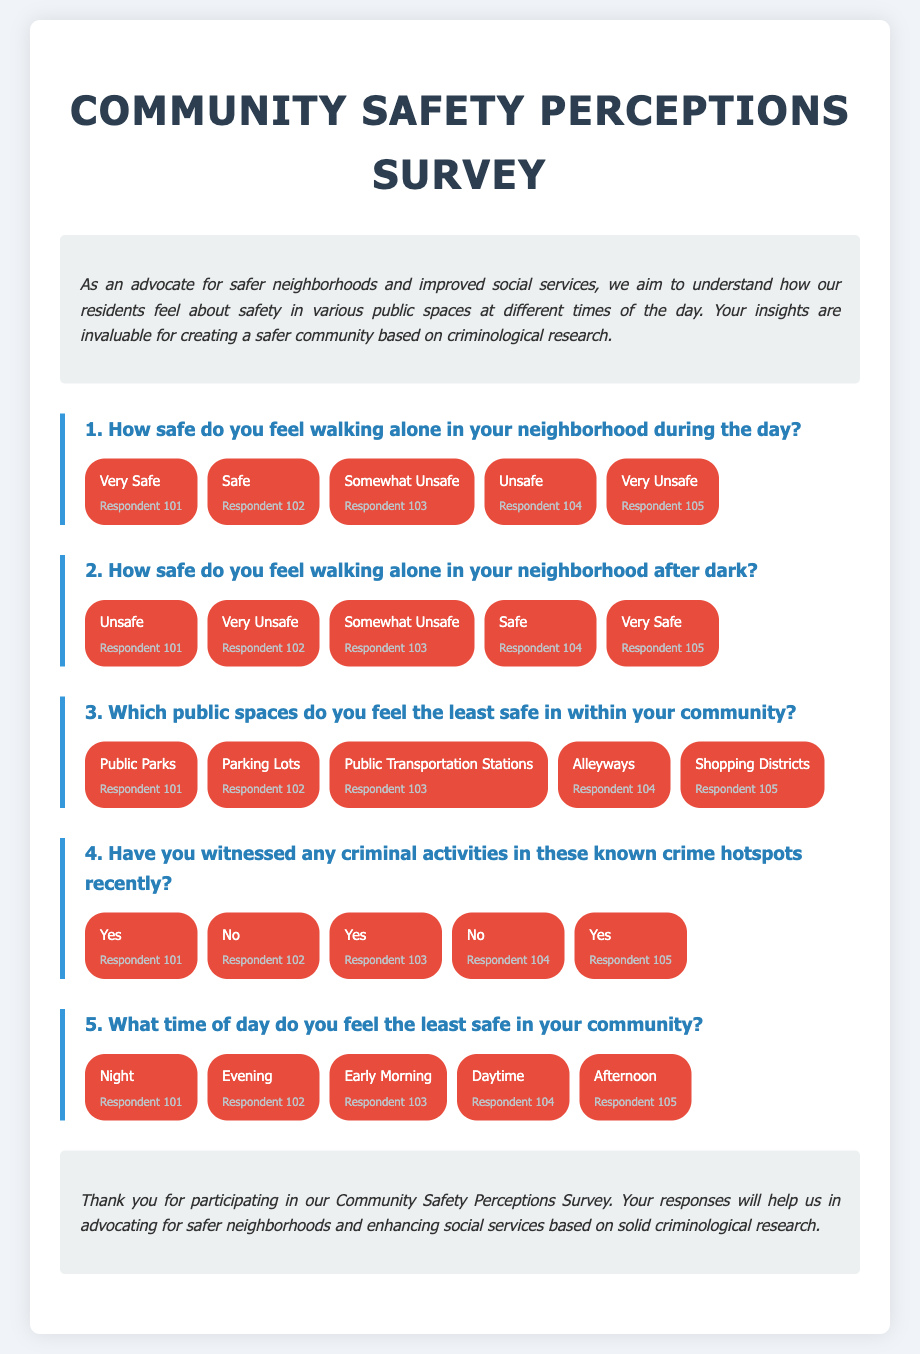What is the title of the survey? The title of the survey is displayed at the top of the document in a large font.
Answer: Community Safety Perceptions Survey How many respondents feel "Very Safe" walking alone during the day? The document lists the number of responses for each category under the respective question regarding safety during the day.
Answer: 1 Which public space is mentioned as the least safe by a respondent? The responses indicate specific public spaces where residents feel least safe within the community.
Answer: Public Parks How many respondents reported witnessing criminal activities recently? The document provides a count of responses under the question about witnessing criminal activities in known crime hotspots.
Answer: 3 What time of day do most respondents feel the least safe? The responses to the question about the least safe time of day give insight into community perceptions at different times.
Answer: Night How many responses indicated "Unsafe" for walking alone after dark? The count of responses for the feeling of safety while walking alone after dark shows the level of concern among residents.
Answer: 2 What is stated in the conclusion of the document? The conclusion summarizes the purpose of the survey and thanks the participants for their responses.
Answer: Thank you for participating in our Community Safety Perceptions Survey 